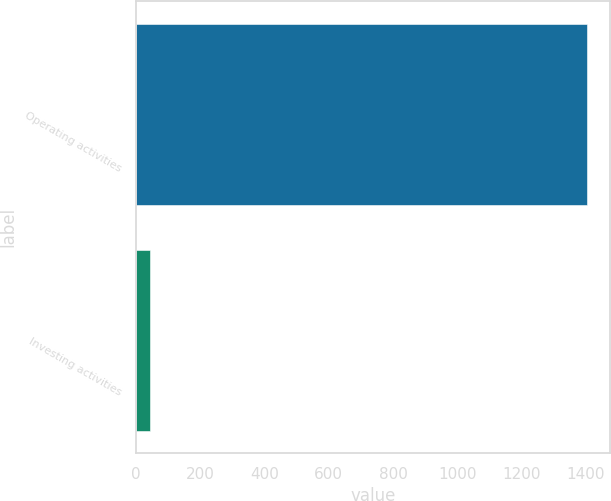Convert chart. <chart><loc_0><loc_0><loc_500><loc_500><bar_chart><fcel>Operating activities<fcel>Investing activities<nl><fcel>1405<fcel>42<nl></chart> 